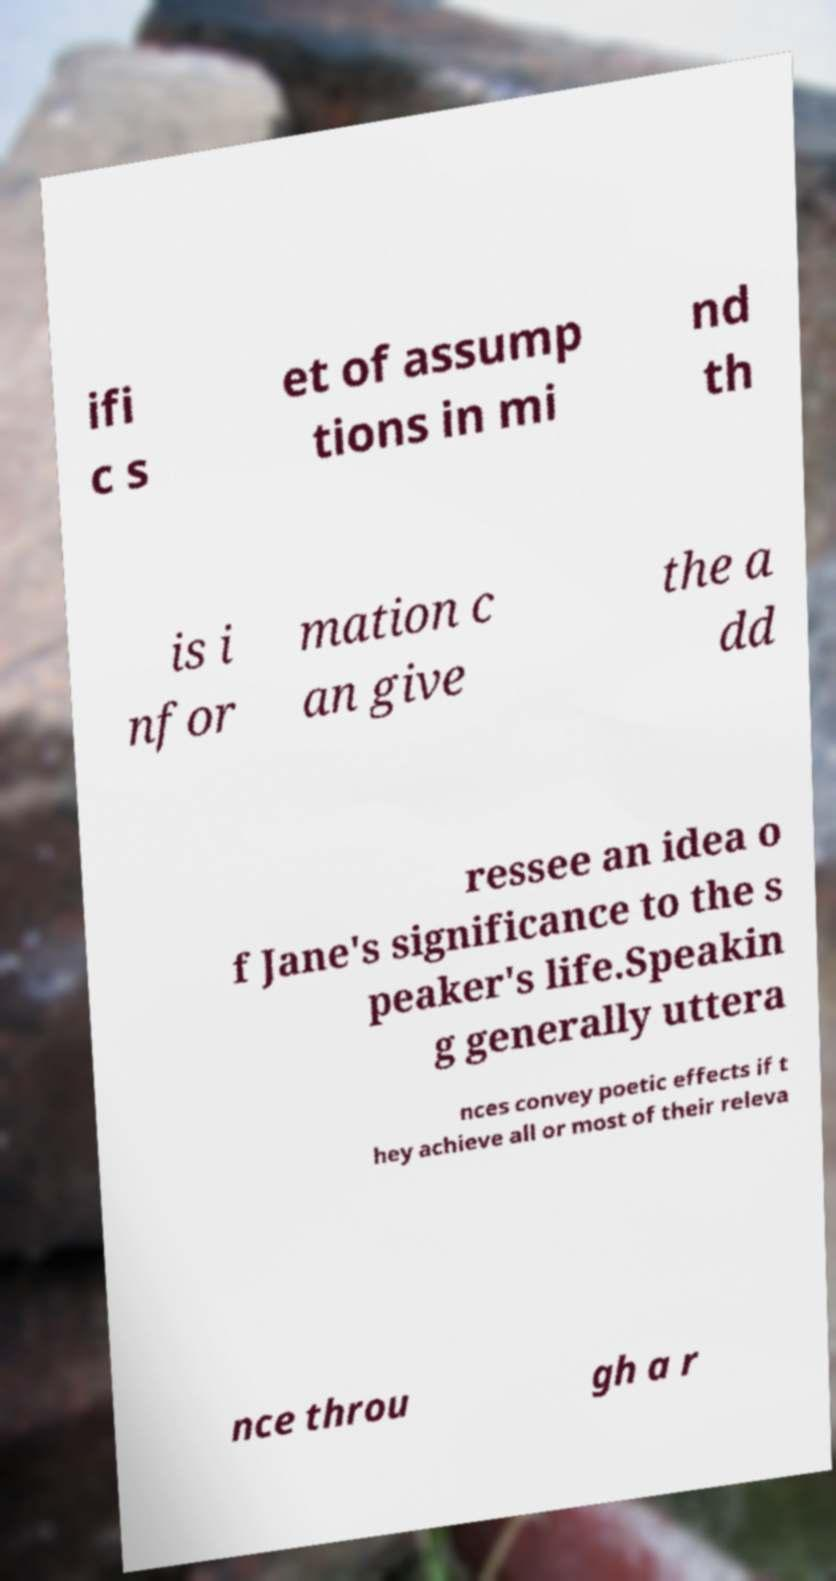Can you read and provide the text displayed in the image?This photo seems to have some interesting text. Can you extract and type it out for me? ifi c s et of assump tions in mi nd th is i nfor mation c an give the a dd ressee an idea o f Jane's significance to the s peaker's life.Speakin g generally uttera nces convey poetic effects if t hey achieve all or most of their releva nce throu gh a r 